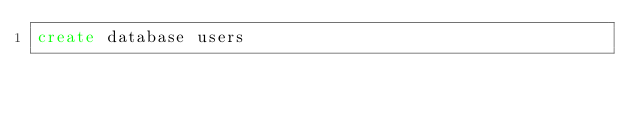<code> <loc_0><loc_0><loc_500><loc_500><_SQL_>create database users</code> 